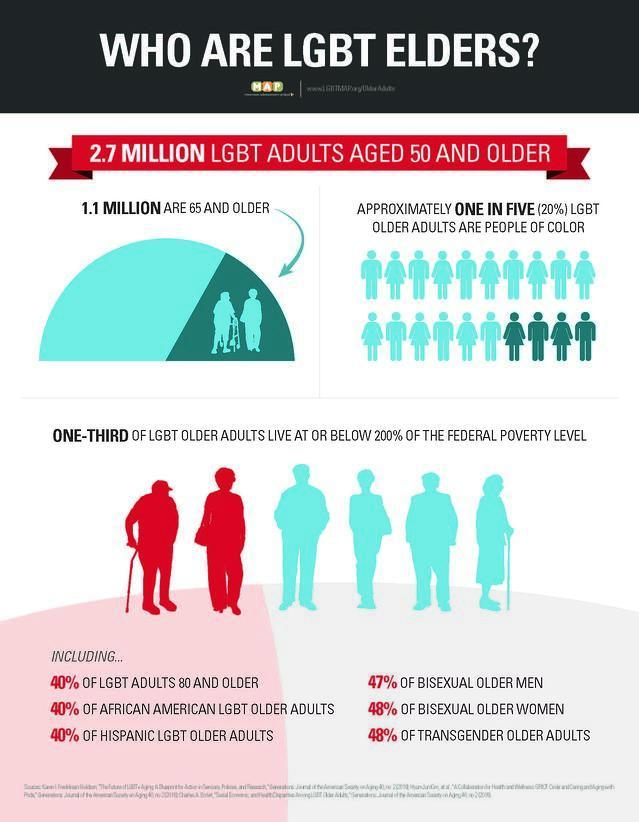What is the population of LGBT elders who are aged 65 and above?
Answer the question with a short phrase. 1.1 Million 